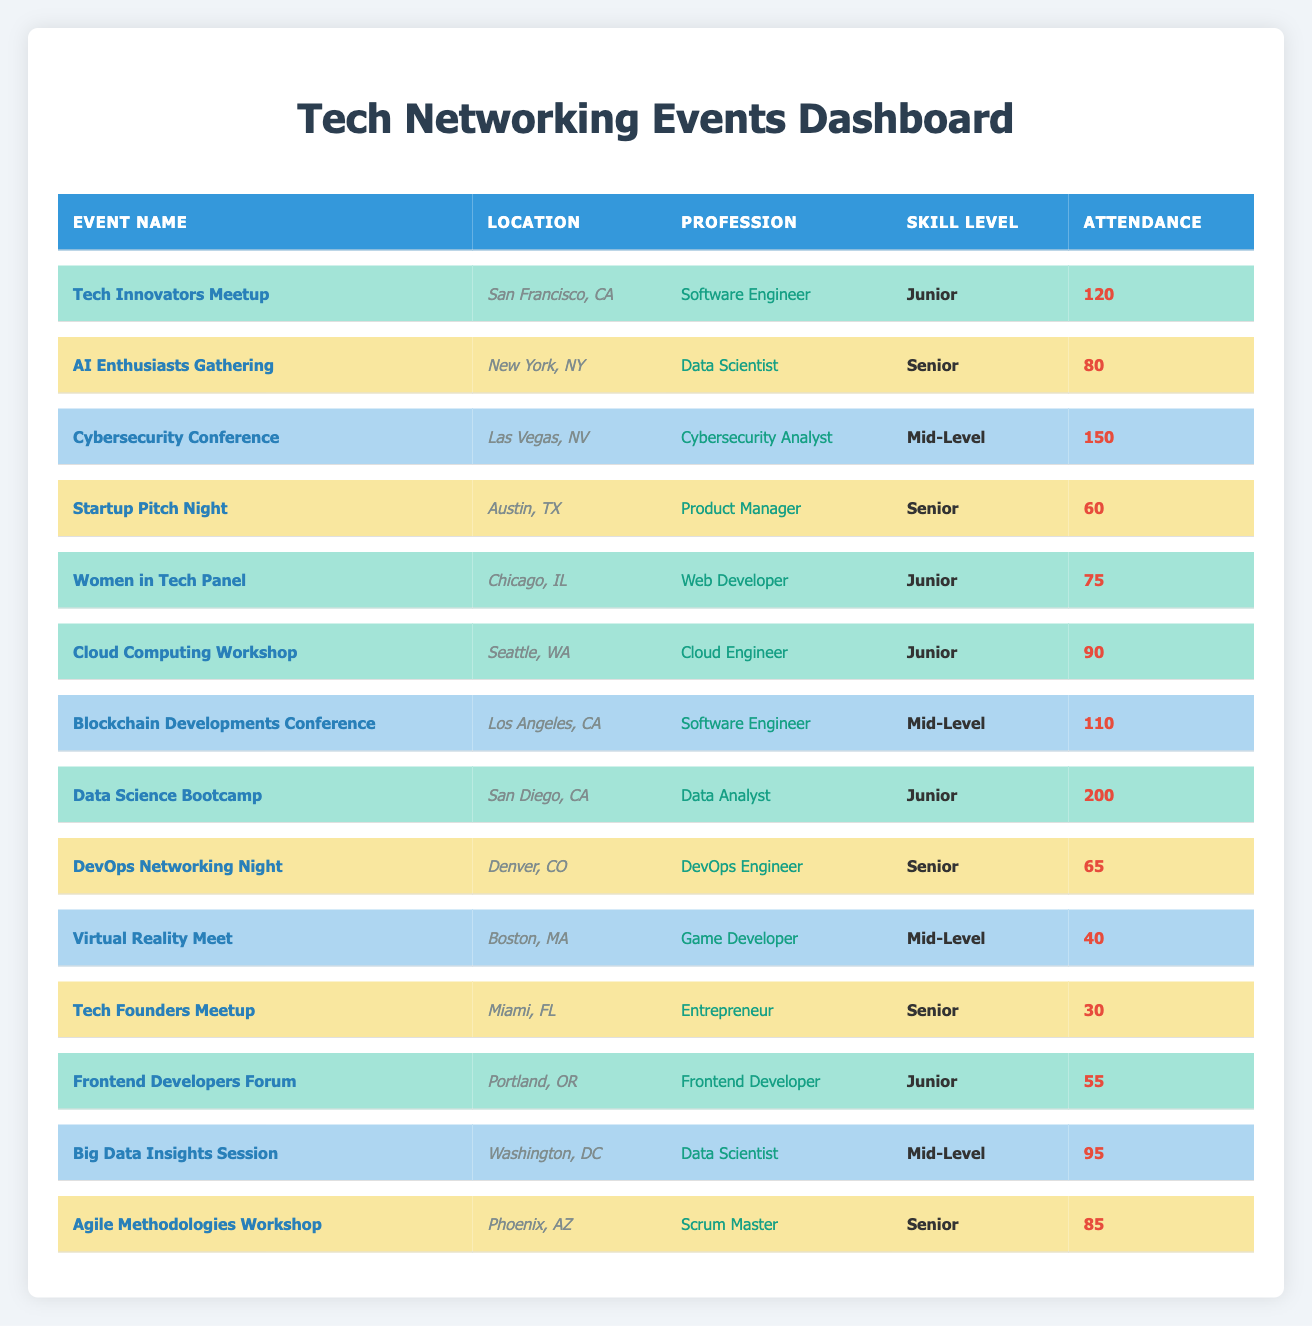What is the attendance at the "Data Science Bootcamp" event? The "Data Science Bootcamp" is listed in the table, and the attendance is specified next to it. By looking at the corresponding row, I see that the attendance is 200.
Answer: 200 Which event had the highest attendance? To find the highest attendance, I scan through all the attendance numbers in the table. The highest attendance listed is 200 for the "Data Science Bootcamp."
Answer: Data Science Bootcamp How many events were attended by professionals at the Junior skill level? I go through the table and count the number of entries marked as "Junior" in the skill level column. There are 5 such events in total.
Answer: 5 Is there an event with "Product Manager" as the profession? The table shows various events and their corresponding professions. In the "Startup Pitch Night" entry, "Product Manager" is mentioned as the profession, confirming that there is indeed an event for this profession.
Answer: Yes What is the total attendance for all events categorized as "Senior"? I identify all entries in the table where the skill level is "Senior." The attendance numbers for these events are 80, 60, 65, 30, and 85. Summing these values gives me 80 + 60 + 65 + 30 + 85 = 320.
Answer: 320 Which city hosted the "Cybersecurity Conference"? The row corresponding to the "Cybersecurity Conference" shows that it took place in Las Vegas, NV.
Answer: Las Vegas, NV How many more attendees were present at the "Cloud Computing Workshop" compared to the "DevOps Networking Night"? I find the attendance for both events: "Cloud Computing Workshop" has 90 attendees, and "DevOps Networking Night" has 65. So, 90 - 65 = 25 attendees more at the workshop.
Answer: 25 What is the average attendance for events led by "Data Scientists"? The events led by "Data Scientists" are "AI Enthusiasts Gathering" with 80 attendees and "Big Data Insights Session" with 95 attendees. The average is calculated as (80 + 95) / 2 = 87.5.
Answer: 87.5 Is "Software Engineer" listed as a profession in both Junior and Mid-Level skill categories? I check for entries with "Software Engineer" in the profession column. The table shows one entry under Junior and one under Mid-Level, confirming that "Software Engineer" is present in both categories.
Answer: Yes What is the difference in attendance between the highest and lowest attended events? The highest attended event is the "Data Science Bootcamp" with 200 attendees, and the lowest is the "Tech Founders Meetup" with 30 attendees. Thus, the difference is 200 - 30 = 170.
Answer: 170 